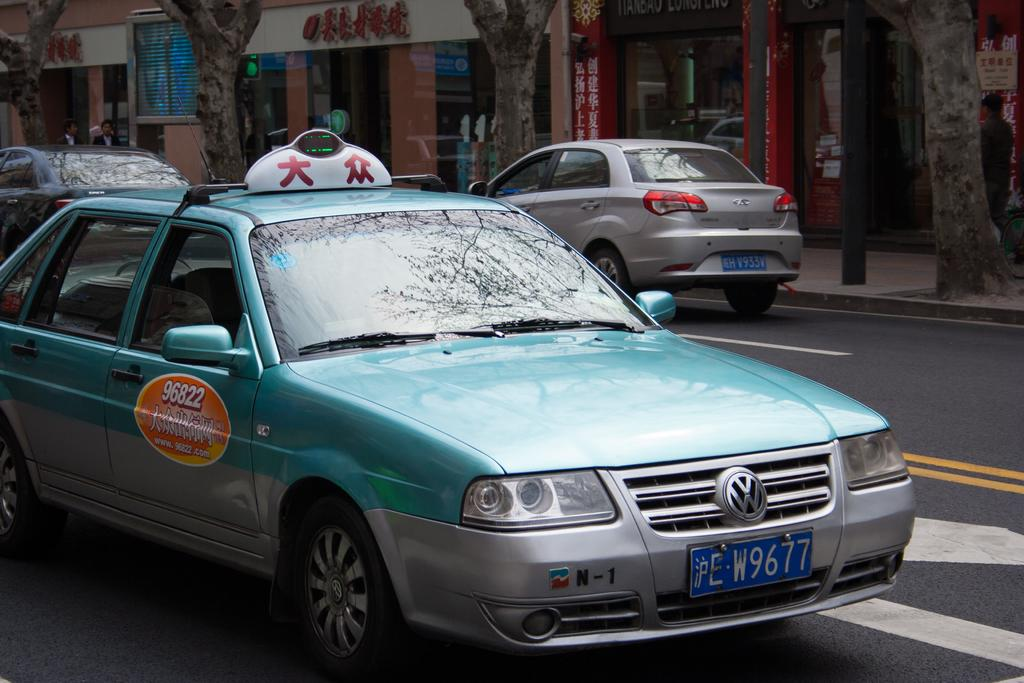<image>
Relay a brief, clear account of the picture shown. The graphic on the door of this bright blue taxi indicates their phone number is 96822. 